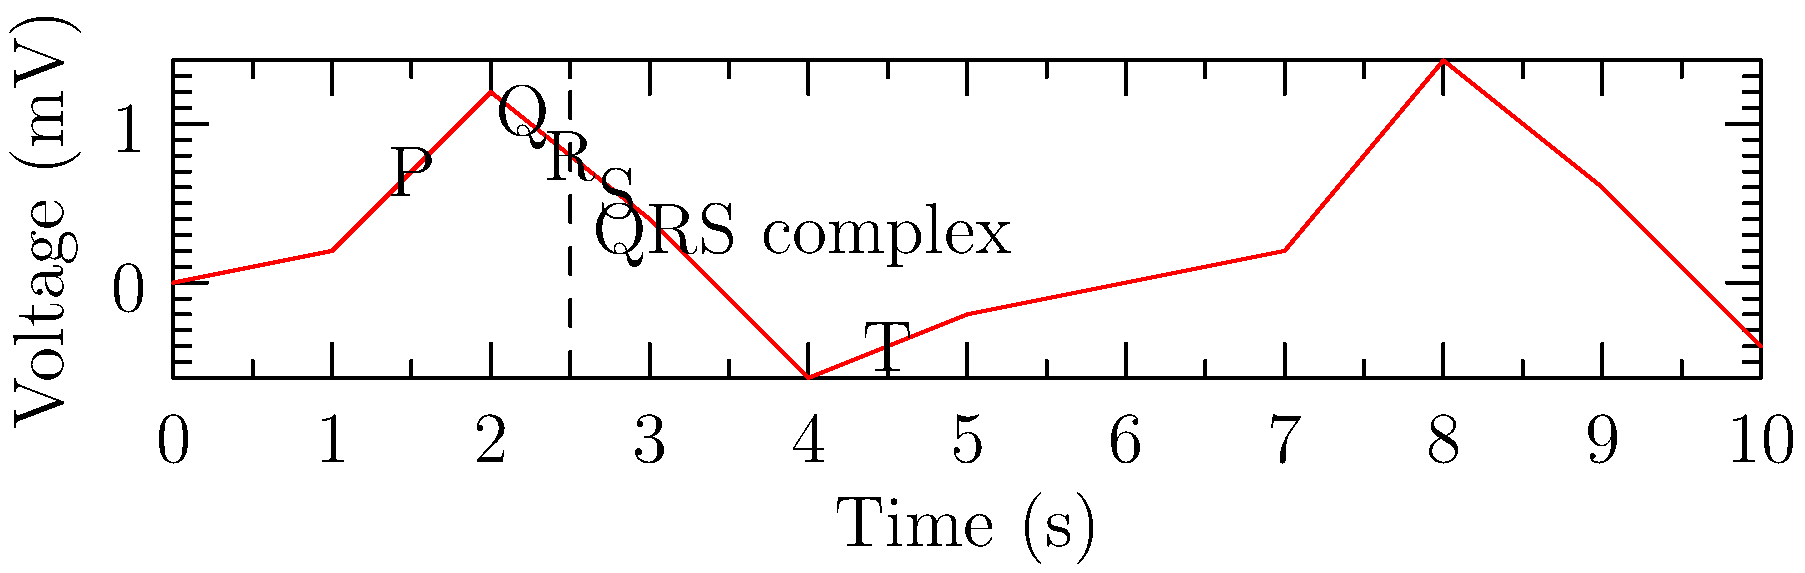Analyze the ECG waveform provided. Which of the following cardiac abnormalities is most likely represented by this ECG pattern?

A) Left bundle branch block
B) Right ventricular hypertrophy
C) Atrial fibrillation
D) Left atrial enlargement To interpret this ECG waveform and identify the most likely cardiac abnormality, let's analyze the key components:

1. P wave: Present and normal, indicating normal atrial depolarization.
2. QRS complex: 
   a) Duration: Appears prolonged (> 0.12 seconds)
   b) Morphology: Wide and notched, especially in the S wave
3. T wave: Present and normal
4. PR interval: Normal
5. ST segment: No significant elevation or depression

Step-by-step analysis:
1. The presence of normal P waves rules out atrial fibrillation (option C).
2. There's no evidence of increased R wave amplitude in V1 or right precordial leads, so right ventricular hypertrophy (option B) is unlikely.
3. The P wave appears normal in amplitude and duration, making left atrial enlargement (option D) improbable.
4. The key feature here is the wide, notched QRS complex with a prolonged duration. This is characteristic of a left bundle branch block (LBBB).

LBBB typically presents with:
- QRS duration > 0.12 seconds
- Broad, notched, or slurred R wave in leads I, aVL, V5, and V6
- Absence of Q waves in leads I, V5, and V6
- ST and T wave discordance (opposite to the main QRS deflection)

The ECG pattern shown matches these criteria for LBBB, making it the most likely diagnosis among the given options.
Answer: Left bundle branch block 